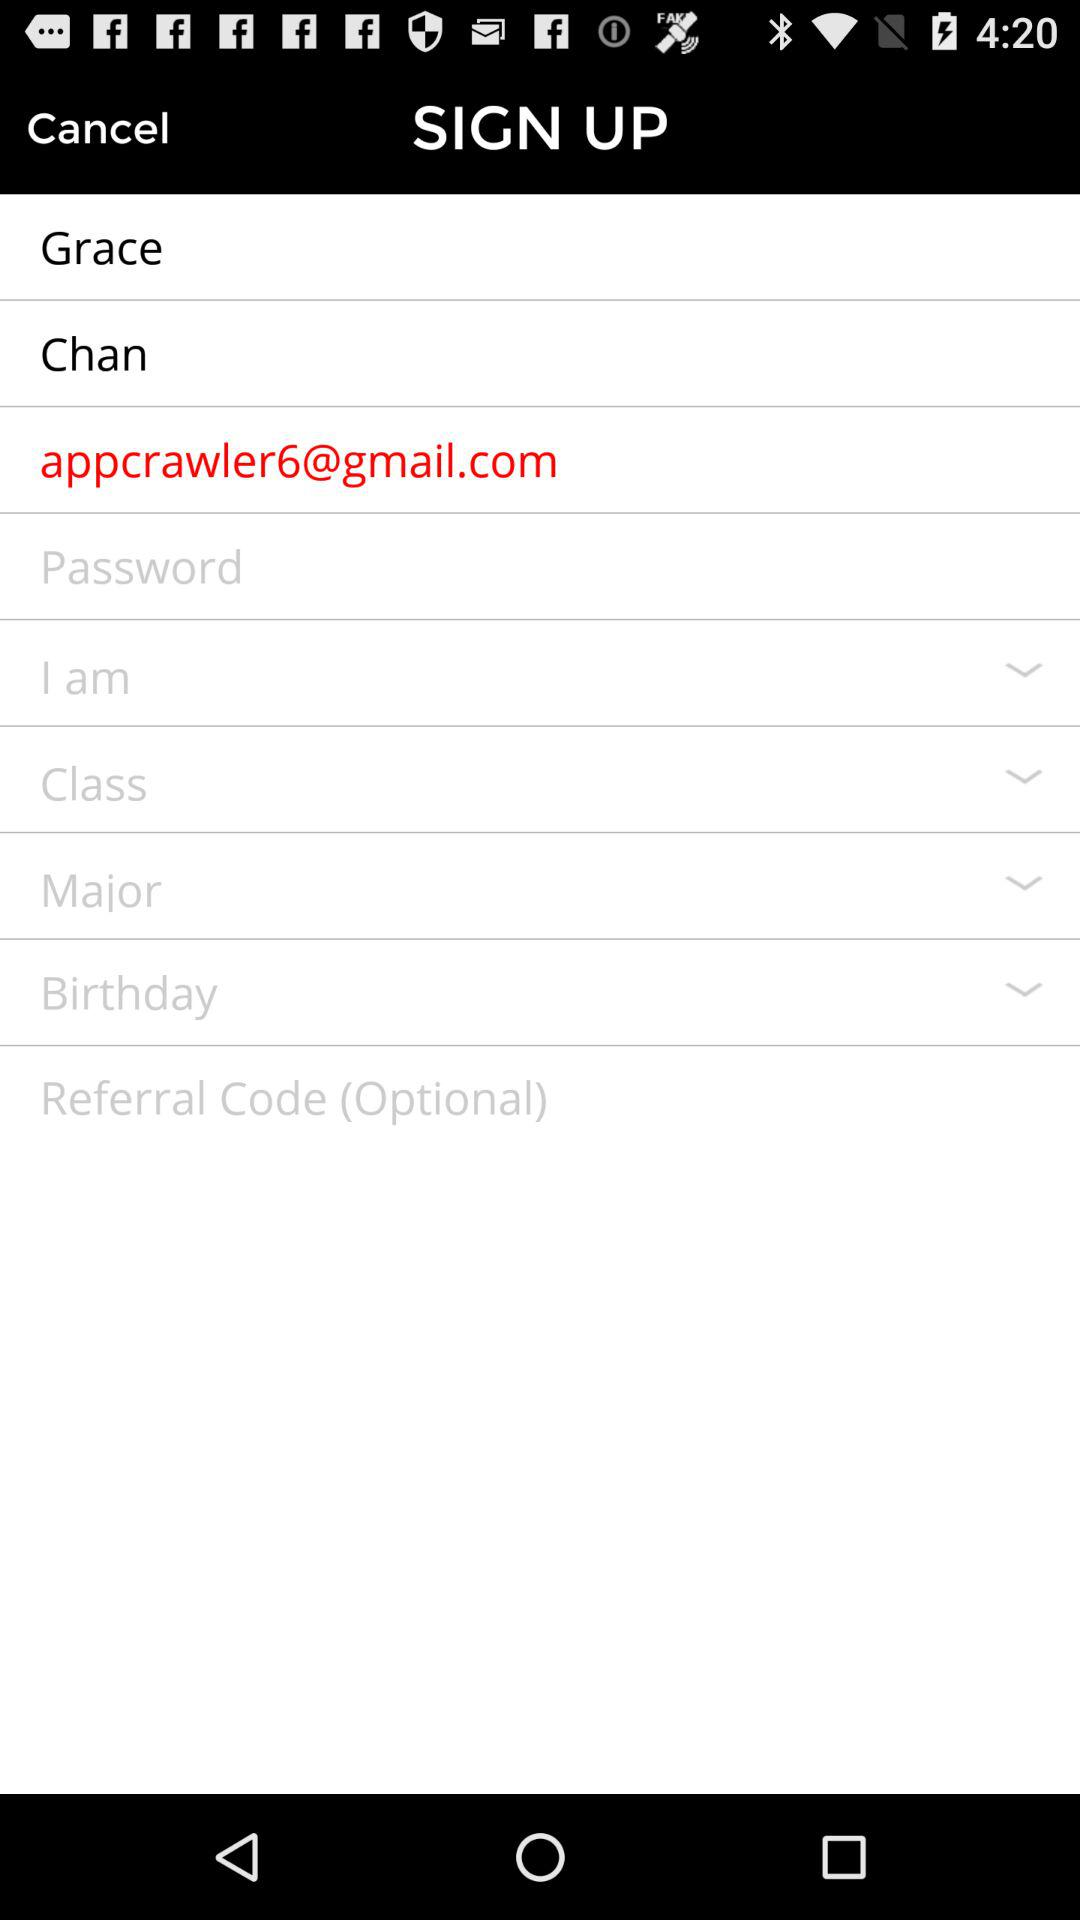What is the name of the person? The name of the person is Grace Chan. 